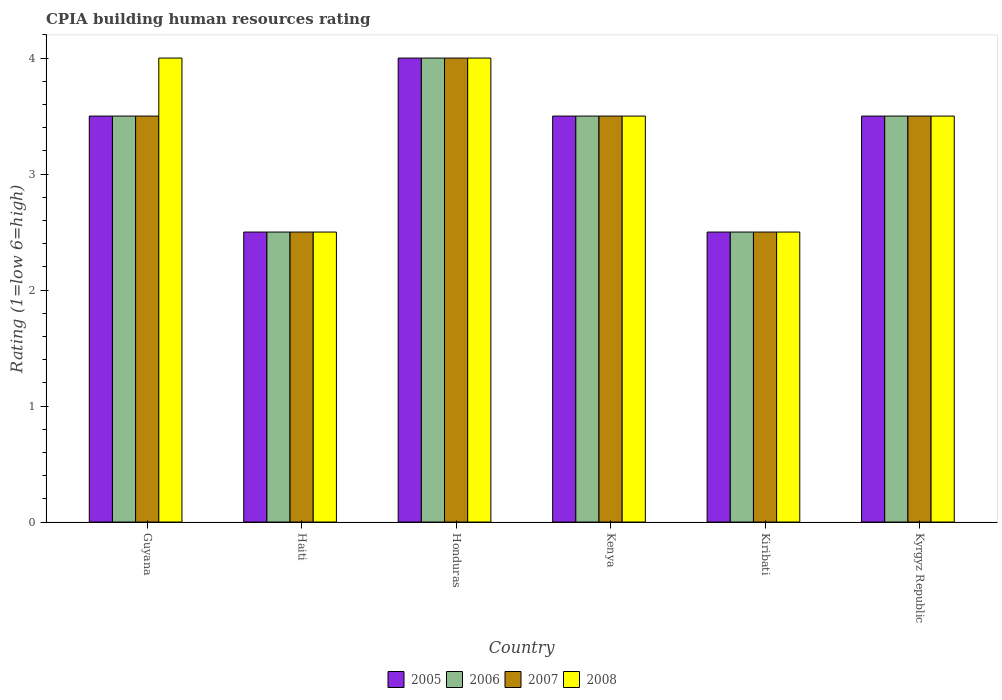How many different coloured bars are there?
Give a very brief answer. 4. How many bars are there on the 6th tick from the left?
Offer a terse response. 4. How many bars are there on the 3rd tick from the right?
Your response must be concise. 4. What is the label of the 1st group of bars from the left?
Offer a terse response. Guyana. In how many cases, is the number of bars for a given country not equal to the number of legend labels?
Make the answer very short. 0. Across all countries, what is the maximum CPIA rating in 2007?
Provide a short and direct response. 4. In which country was the CPIA rating in 2005 maximum?
Ensure brevity in your answer.  Honduras. In which country was the CPIA rating in 2006 minimum?
Your answer should be compact. Haiti. What is the average CPIA rating in 2006 per country?
Offer a very short reply. 3.25. What is the ratio of the CPIA rating in 2005 in Guyana to that in Honduras?
Keep it short and to the point. 0.88. Is the CPIA rating in 2008 in Kiribati less than that in Kyrgyz Republic?
Ensure brevity in your answer.  Yes. What is the difference between the highest and the second highest CPIA rating in 2007?
Your answer should be very brief. -0.5. Is the sum of the CPIA rating in 2006 in Honduras and Kyrgyz Republic greater than the maximum CPIA rating in 2005 across all countries?
Your answer should be compact. Yes. Is it the case that in every country, the sum of the CPIA rating in 2008 and CPIA rating in 2007 is greater than the sum of CPIA rating in 2006 and CPIA rating in 2005?
Your answer should be compact. No. How many countries are there in the graph?
Your answer should be very brief. 6. What is the difference between two consecutive major ticks on the Y-axis?
Ensure brevity in your answer.  1. Are the values on the major ticks of Y-axis written in scientific E-notation?
Your answer should be very brief. No. Where does the legend appear in the graph?
Keep it short and to the point. Bottom center. How many legend labels are there?
Give a very brief answer. 4. How are the legend labels stacked?
Your response must be concise. Horizontal. What is the title of the graph?
Your response must be concise. CPIA building human resources rating. Does "2004" appear as one of the legend labels in the graph?
Your answer should be compact. No. What is the label or title of the X-axis?
Give a very brief answer. Country. What is the Rating (1=low 6=high) of 2006 in Guyana?
Ensure brevity in your answer.  3.5. What is the Rating (1=low 6=high) of 2007 in Guyana?
Provide a short and direct response. 3.5. What is the Rating (1=low 6=high) of 2005 in Honduras?
Make the answer very short. 4. What is the Rating (1=low 6=high) in 2006 in Kenya?
Keep it short and to the point. 3.5. What is the Rating (1=low 6=high) in 2008 in Kenya?
Provide a succinct answer. 3.5. What is the Rating (1=low 6=high) of 2005 in Kiribati?
Your response must be concise. 2.5. What is the Rating (1=low 6=high) in 2006 in Kiribati?
Provide a short and direct response. 2.5. What is the Rating (1=low 6=high) in 2007 in Kiribati?
Offer a very short reply. 2.5. What is the Rating (1=low 6=high) of 2006 in Kyrgyz Republic?
Offer a very short reply. 3.5. Across all countries, what is the maximum Rating (1=low 6=high) of 2005?
Give a very brief answer. 4. Across all countries, what is the maximum Rating (1=low 6=high) of 2008?
Your response must be concise. 4. Across all countries, what is the minimum Rating (1=low 6=high) in 2005?
Ensure brevity in your answer.  2.5. Across all countries, what is the minimum Rating (1=low 6=high) in 2006?
Your answer should be compact. 2.5. What is the total Rating (1=low 6=high) in 2005 in the graph?
Offer a terse response. 19.5. What is the total Rating (1=low 6=high) of 2006 in the graph?
Your answer should be compact. 19.5. What is the total Rating (1=low 6=high) in 2007 in the graph?
Provide a short and direct response. 19.5. What is the total Rating (1=low 6=high) of 2008 in the graph?
Provide a succinct answer. 20. What is the difference between the Rating (1=low 6=high) of 2006 in Guyana and that in Haiti?
Your answer should be compact. 1. What is the difference between the Rating (1=low 6=high) of 2007 in Guyana and that in Haiti?
Your answer should be compact. 1. What is the difference between the Rating (1=low 6=high) in 2008 in Guyana and that in Haiti?
Give a very brief answer. 1.5. What is the difference between the Rating (1=low 6=high) of 2005 in Guyana and that in Honduras?
Offer a very short reply. -0.5. What is the difference between the Rating (1=low 6=high) in 2005 in Guyana and that in Kenya?
Make the answer very short. 0. What is the difference between the Rating (1=low 6=high) in 2006 in Guyana and that in Kenya?
Offer a very short reply. 0. What is the difference between the Rating (1=low 6=high) in 2008 in Guyana and that in Kenya?
Provide a short and direct response. 0.5. What is the difference between the Rating (1=low 6=high) of 2005 in Guyana and that in Kiribati?
Provide a succinct answer. 1. What is the difference between the Rating (1=low 6=high) of 2006 in Guyana and that in Kiribati?
Offer a terse response. 1. What is the difference between the Rating (1=low 6=high) of 2007 in Guyana and that in Kiribati?
Give a very brief answer. 1. What is the difference between the Rating (1=low 6=high) in 2007 in Guyana and that in Kyrgyz Republic?
Offer a terse response. 0. What is the difference between the Rating (1=low 6=high) of 2005 in Haiti and that in Honduras?
Your answer should be compact. -1.5. What is the difference between the Rating (1=low 6=high) of 2005 in Haiti and that in Kenya?
Ensure brevity in your answer.  -1. What is the difference between the Rating (1=low 6=high) in 2008 in Haiti and that in Kenya?
Your answer should be compact. -1. What is the difference between the Rating (1=low 6=high) of 2007 in Haiti and that in Kiribati?
Your response must be concise. 0. What is the difference between the Rating (1=low 6=high) in 2008 in Haiti and that in Kiribati?
Keep it short and to the point. 0. What is the difference between the Rating (1=low 6=high) in 2006 in Haiti and that in Kyrgyz Republic?
Offer a very short reply. -1. What is the difference between the Rating (1=low 6=high) in 2007 in Honduras and that in Kenya?
Your answer should be compact. 0.5. What is the difference between the Rating (1=low 6=high) in 2008 in Honduras and that in Kenya?
Give a very brief answer. 0.5. What is the difference between the Rating (1=low 6=high) in 2005 in Honduras and that in Kiribati?
Give a very brief answer. 1.5. What is the difference between the Rating (1=low 6=high) in 2006 in Honduras and that in Kiribati?
Your answer should be compact. 1.5. What is the difference between the Rating (1=low 6=high) in 2005 in Honduras and that in Kyrgyz Republic?
Provide a succinct answer. 0.5. What is the difference between the Rating (1=low 6=high) in 2007 in Honduras and that in Kyrgyz Republic?
Your response must be concise. 0.5. What is the difference between the Rating (1=low 6=high) in 2008 in Honduras and that in Kyrgyz Republic?
Provide a short and direct response. 0.5. What is the difference between the Rating (1=low 6=high) of 2005 in Kenya and that in Kyrgyz Republic?
Offer a terse response. 0. What is the difference between the Rating (1=low 6=high) of 2006 in Kenya and that in Kyrgyz Republic?
Keep it short and to the point. 0. What is the difference between the Rating (1=low 6=high) of 2008 in Kenya and that in Kyrgyz Republic?
Your response must be concise. 0. What is the difference between the Rating (1=low 6=high) of 2006 in Kiribati and that in Kyrgyz Republic?
Keep it short and to the point. -1. What is the difference between the Rating (1=low 6=high) of 2007 in Kiribati and that in Kyrgyz Republic?
Keep it short and to the point. -1. What is the difference between the Rating (1=low 6=high) in 2008 in Kiribati and that in Kyrgyz Republic?
Your answer should be very brief. -1. What is the difference between the Rating (1=low 6=high) of 2006 in Guyana and the Rating (1=low 6=high) of 2008 in Haiti?
Ensure brevity in your answer.  1. What is the difference between the Rating (1=low 6=high) of 2006 in Guyana and the Rating (1=low 6=high) of 2007 in Honduras?
Offer a terse response. -0.5. What is the difference between the Rating (1=low 6=high) of 2006 in Guyana and the Rating (1=low 6=high) of 2008 in Honduras?
Make the answer very short. -0.5. What is the difference between the Rating (1=low 6=high) of 2007 in Guyana and the Rating (1=low 6=high) of 2008 in Honduras?
Provide a succinct answer. -0.5. What is the difference between the Rating (1=low 6=high) in 2005 in Guyana and the Rating (1=low 6=high) in 2006 in Kenya?
Make the answer very short. 0. What is the difference between the Rating (1=low 6=high) in 2006 in Guyana and the Rating (1=low 6=high) in 2007 in Kenya?
Ensure brevity in your answer.  0. What is the difference between the Rating (1=low 6=high) of 2006 in Guyana and the Rating (1=low 6=high) of 2008 in Kenya?
Provide a succinct answer. 0. What is the difference between the Rating (1=low 6=high) of 2007 in Guyana and the Rating (1=low 6=high) of 2008 in Kenya?
Give a very brief answer. 0. What is the difference between the Rating (1=low 6=high) of 2006 in Guyana and the Rating (1=low 6=high) of 2008 in Kiribati?
Provide a succinct answer. 1. What is the difference between the Rating (1=low 6=high) in 2005 in Guyana and the Rating (1=low 6=high) in 2008 in Kyrgyz Republic?
Keep it short and to the point. 0. What is the difference between the Rating (1=low 6=high) of 2006 in Guyana and the Rating (1=low 6=high) of 2008 in Kyrgyz Republic?
Keep it short and to the point. 0. What is the difference between the Rating (1=low 6=high) of 2005 in Haiti and the Rating (1=low 6=high) of 2007 in Honduras?
Offer a very short reply. -1.5. What is the difference between the Rating (1=low 6=high) in 2006 in Haiti and the Rating (1=low 6=high) in 2007 in Honduras?
Your response must be concise. -1.5. What is the difference between the Rating (1=low 6=high) of 2007 in Haiti and the Rating (1=low 6=high) of 2008 in Honduras?
Provide a succinct answer. -1.5. What is the difference between the Rating (1=low 6=high) in 2005 in Haiti and the Rating (1=low 6=high) in 2006 in Kenya?
Keep it short and to the point. -1. What is the difference between the Rating (1=low 6=high) in 2005 in Haiti and the Rating (1=low 6=high) in 2008 in Kenya?
Make the answer very short. -1. What is the difference between the Rating (1=low 6=high) in 2006 in Haiti and the Rating (1=low 6=high) in 2007 in Kenya?
Give a very brief answer. -1. What is the difference between the Rating (1=low 6=high) of 2005 in Haiti and the Rating (1=low 6=high) of 2007 in Kiribati?
Provide a succinct answer. 0. What is the difference between the Rating (1=low 6=high) of 2007 in Haiti and the Rating (1=low 6=high) of 2008 in Kiribati?
Your answer should be very brief. 0. What is the difference between the Rating (1=low 6=high) in 2005 in Haiti and the Rating (1=low 6=high) in 2007 in Kyrgyz Republic?
Make the answer very short. -1. What is the difference between the Rating (1=low 6=high) in 2005 in Haiti and the Rating (1=low 6=high) in 2008 in Kyrgyz Republic?
Provide a short and direct response. -1. What is the difference between the Rating (1=low 6=high) of 2006 in Haiti and the Rating (1=low 6=high) of 2007 in Kyrgyz Republic?
Make the answer very short. -1. What is the difference between the Rating (1=low 6=high) in 2005 in Honduras and the Rating (1=low 6=high) in 2006 in Kenya?
Ensure brevity in your answer.  0.5. What is the difference between the Rating (1=low 6=high) in 2005 in Honduras and the Rating (1=low 6=high) in 2008 in Kenya?
Provide a succinct answer. 0.5. What is the difference between the Rating (1=low 6=high) of 2006 in Honduras and the Rating (1=low 6=high) of 2007 in Kenya?
Offer a terse response. 0.5. What is the difference between the Rating (1=low 6=high) of 2006 in Honduras and the Rating (1=low 6=high) of 2008 in Kenya?
Keep it short and to the point. 0.5. What is the difference between the Rating (1=low 6=high) of 2005 in Honduras and the Rating (1=low 6=high) of 2007 in Kiribati?
Your answer should be very brief. 1.5. What is the difference between the Rating (1=low 6=high) of 2006 in Honduras and the Rating (1=low 6=high) of 2007 in Kiribati?
Offer a terse response. 1.5. What is the difference between the Rating (1=low 6=high) of 2006 in Honduras and the Rating (1=low 6=high) of 2008 in Kiribati?
Provide a succinct answer. 1.5. What is the difference between the Rating (1=low 6=high) of 2007 in Honduras and the Rating (1=low 6=high) of 2008 in Kiribati?
Make the answer very short. 1.5. What is the difference between the Rating (1=low 6=high) in 2005 in Honduras and the Rating (1=low 6=high) in 2006 in Kyrgyz Republic?
Offer a very short reply. 0.5. What is the difference between the Rating (1=low 6=high) of 2006 in Honduras and the Rating (1=low 6=high) of 2007 in Kyrgyz Republic?
Provide a short and direct response. 0.5. What is the difference between the Rating (1=low 6=high) in 2006 in Honduras and the Rating (1=low 6=high) in 2008 in Kyrgyz Republic?
Make the answer very short. 0.5. What is the difference between the Rating (1=low 6=high) in 2007 in Honduras and the Rating (1=low 6=high) in 2008 in Kyrgyz Republic?
Provide a succinct answer. 0.5. What is the difference between the Rating (1=low 6=high) of 2005 in Kenya and the Rating (1=low 6=high) of 2008 in Kiribati?
Your answer should be compact. 1. What is the difference between the Rating (1=low 6=high) in 2006 in Kenya and the Rating (1=low 6=high) in 2007 in Kiribati?
Provide a succinct answer. 1. What is the difference between the Rating (1=low 6=high) in 2007 in Kenya and the Rating (1=low 6=high) in 2008 in Kiribati?
Make the answer very short. 1. What is the difference between the Rating (1=low 6=high) of 2005 in Kenya and the Rating (1=low 6=high) of 2008 in Kyrgyz Republic?
Offer a terse response. 0. What is the difference between the Rating (1=low 6=high) of 2006 in Kenya and the Rating (1=low 6=high) of 2007 in Kyrgyz Republic?
Your answer should be compact. 0. What is the difference between the Rating (1=low 6=high) of 2006 in Kenya and the Rating (1=low 6=high) of 2008 in Kyrgyz Republic?
Make the answer very short. 0. What is the difference between the Rating (1=low 6=high) in 2007 in Kenya and the Rating (1=low 6=high) in 2008 in Kyrgyz Republic?
Provide a short and direct response. 0. What is the difference between the Rating (1=low 6=high) of 2006 in Kiribati and the Rating (1=low 6=high) of 2007 in Kyrgyz Republic?
Your answer should be very brief. -1. What is the difference between the Rating (1=low 6=high) of 2007 in Kiribati and the Rating (1=low 6=high) of 2008 in Kyrgyz Republic?
Your answer should be very brief. -1. What is the average Rating (1=low 6=high) of 2005 per country?
Your response must be concise. 3.25. What is the average Rating (1=low 6=high) of 2006 per country?
Make the answer very short. 3.25. What is the average Rating (1=low 6=high) in 2008 per country?
Your answer should be very brief. 3.33. What is the difference between the Rating (1=low 6=high) in 2005 and Rating (1=low 6=high) in 2007 in Guyana?
Your response must be concise. 0. What is the difference between the Rating (1=low 6=high) in 2005 and Rating (1=low 6=high) in 2006 in Haiti?
Make the answer very short. 0. What is the difference between the Rating (1=low 6=high) in 2005 and Rating (1=low 6=high) in 2007 in Haiti?
Ensure brevity in your answer.  0. What is the difference between the Rating (1=low 6=high) in 2005 and Rating (1=low 6=high) in 2008 in Haiti?
Offer a terse response. 0. What is the difference between the Rating (1=low 6=high) of 2006 and Rating (1=low 6=high) of 2007 in Haiti?
Give a very brief answer. 0. What is the difference between the Rating (1=low 6=high) in 2005 and Rating (1=low 6=high) in 2007 in Honduras?
Your response must be concise. 0. What is the difference between the Rating (1=low 6=high) of 2006 and Rating (1=low 6=high) of 2007 in Honduras?
Provide a short and direct response. 0. What is the difference between the Rating (1=low 6=high) of 2006 and Rating (1=low 6=high) of 2008 in Honduras?
Offer a very short reply. 0. What is the difference between the Rating (1=low 6=high) in 2005 and Rating (1=low 6=high) in 2006 in Kenya?
Offer a very short reply. 0. What is the difference between the Rating (1=low 6=high) in 2006 and Rating (1=low 6=high) in 2007 in Kenya?
Provide a short and direct response. 0. What is the difference between the Rating (1=low 6=high) of 2005 and Rating (1=low 6=high) of 2006 in Kiribati?
Your answer should be compact. 0. What is the difference between the Rating (1=low 6=high) of 2006 and Rating (1=low 6=high) of 2008 in Kiribati?
Make the answer very short. 0. What is the difference between the Rating (1=low 6=high) in 2005 and Rating (1=low 6=high) in 2007 in Kyrgyz Republic?
Make the answer very short. 0. What is the difference between the Rating (1=low 6=high) of 2007 and Rating (1=low 6=high) of 2008 in Kyrgyz Republic?
Ensure brevity in your answer.  0. What is the ratio of the Rating (1=low 6=high) of 2006 in Guyana to that in Haiti?
Make the answer very short. 1.4. What is the ratio of the Rating (1=low 6=high) of 2007 in Guyana to that in Haiti?
Provide a succinct answer. 1.4. What is the ratio of the Rating (1=low 6=high) in 2008 in Guyana to that in Haiti?
Offer a very short reply. 1.6. What is the ratio of the Rating (1=low 6=high) in 2005 in Guyana to that in Honduras?
Your answer should be compact. 0.88. What is the ratio of the Rating (1=low 6=high) of 2006 in Guyana to that in Honduras?
Offer a very short reply. 0.88. What is the ratio of the Rating (1=low 6=high) in 2008 in Guyana to that in Kenya?
Make the answer very short. 1.14. What is the ratio of the Rating (1=low 6=high) in 2006 in Guyana to that in Kiribati?
Keep it short and to the point. 1.4. What is the ratio of the Rating (1=low 6=high) in 2005 in Guyana to that in Kyrgyz Republic?
Give a very brief answer. 1. What is the ratio of the Rating (1=low 6=high) of 2007 in Guyana to that in Kyrgyz Republic?
Your answer should be very brief. 1. What is the ratio of the Rating (1=low 6=high) of 2007 in Haiti to that in Honduras?
Provide a short and direct response. 0.62. What is the ratio of the Rating (1=low 6=high) of 2007 in Haiti to that in Kenya?
Keep it short and to the point. 0.71. What is the ratio of the Rating (1=low 6=high) in 2005 in Haiti to that in Kiribati?
Make the answer very short. 1. What is the ratio of the Rating (1=low 6=high) in 2006 in Haiti to that in Kiribati?
Your answer should be very brief. 1. What is the ratio of the Rating (1=low 6=high) in 2008 in Haiti to that in Kiribati?
Your response must be concise. 1. What is the ratio of the Rating (1=low 6=high) of 2005 in Haiti to that in Kyrgyz Republic?
Provide a succinct answer. 0.71. What is the ratio of the Rating (1=low 6=high) of 2006 in Haiti to that in Kyrgyz Republic?
Your answer should be very brief. 0.71. What is the ratio of the Rating (1=low 6=high) of 2008 in Haiti to that in Kyrgyz Republic?
Make the answer very short. 0.71. What is the ratio of the Rating (1=low 6=high) of 2005 in Honduras to that in Kenya?
Keep it short and to the point. 1.14. What is the ratio of the Rating (1=low 6=high) of 2006 in Honduras to that in Kenya?
Offer a terse response. 1.14. What is the ratio of the Rating (1=low 6=high) of 2007 in Honduras to that in Kiribati?
Give a very brief answer. 1.6. What is the ratio of the Rating (1=low 6=high) in 2005 in Honduras to that in Kyrgyz Republic?
Give a very brief answer. 1.14. What is the ratio of the Rating (1=low 6=high) of 2008 in Honduras to that in Kyrgyz Republic?
Offer a very short reply. 1.14. What is the ratio of the Rating (1=low 6=high) in 2008 in Kenya to that in Kiribati?
Your response must be concise. 1.4. What is the ratio of the Rating (1=low 6=high) of 2008 in Kenya to that in Kyrgyz Republic?
Ensure brevity in your answer.  1. What is the ratio of the Rating (1=low 6=high) in 2008 in Kiribati to that in Kyrgyz Republic?
Your answer should be compact. 0.71. What is the difference between the highest and the second highest Rating (1=low 6=high) of 2005?
Give a very brief answer. 0.5. What is the difference between the highest and the second highest Rating (1=low 6=high) of 2006?
Provide a short and direct response. 0.5. What is the difference between the highest and the second highest Rating (1=low 6=high) of 2007?
Your answer should be very brief. 0.5. What is the difference between the highest and the lowest Rating (1=low 6=high) of 2006?
Provide a short and direct response. 1.5. What is the difference between the highest and the lowest Rating (1=low 6=high) of 2007?
Provide a short and direct response. 1.5. What is the difference between the highest and the lowest Rating (1=low 6=high) in 2008?
Your answer should be compact. 1.5. 